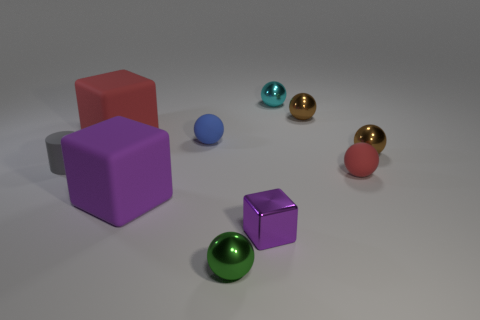Subtract all cyan balls. How many balls are left? 5 Subtract all small green metallic spheres. How many spheres are left? 5 Subtract all green spheres. Subtract all blue cylinders. How many spheres are left? 5 Subtract all blocks. How many objects are left? 7 Add 4 brown shiny objects. How many brown shiny objects exist? 6 Subtract 0 yellow blocks. How many objects are left? 10 Subtract all small cyan metallic balls. Subtract all tiny things. How many objects are left? 1 Add 3 green metallic spheres. How many green metallic spheres are left? 4 